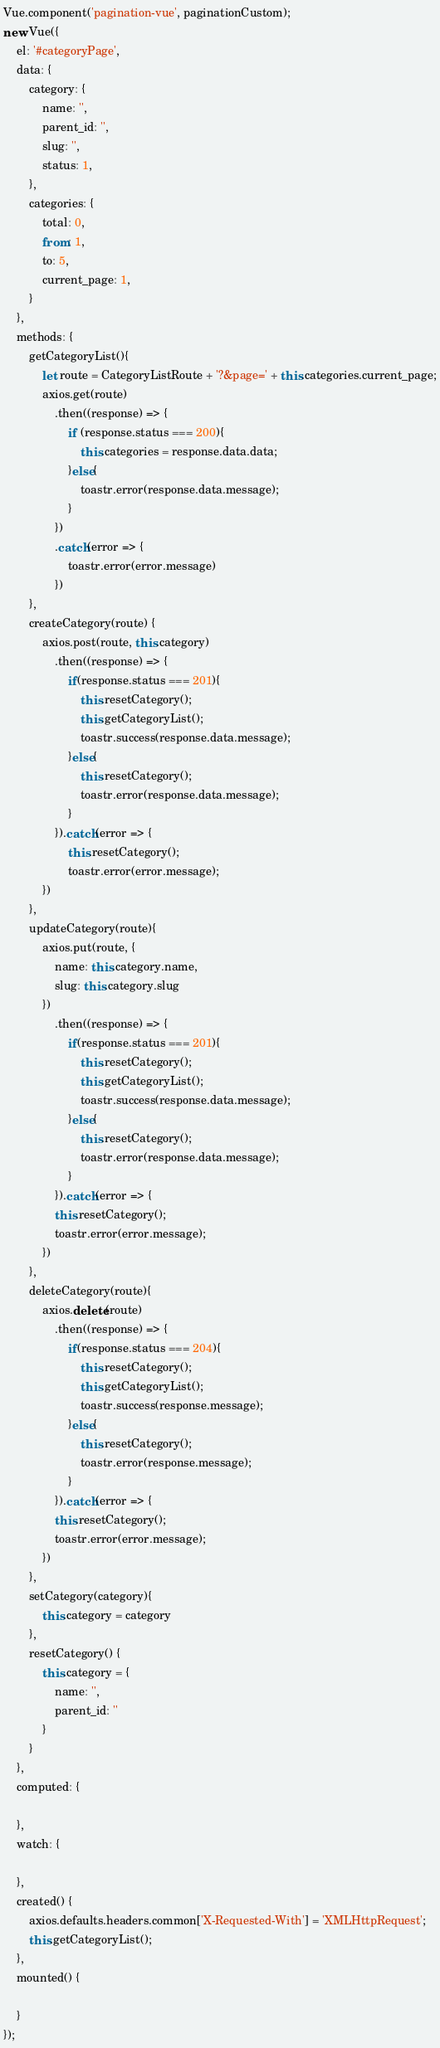Convert code to text. <code><loc_0><loc_0><loc_500><loc_500><_JavaScript_>Vue.component('pagination-vue', paginationCustom);
new Vue({
    el: '#categoryPage',
    data: {
        category: {
            name: '',
            parent_id: '',
            slug: '',
            status: 1,
        },
        categories: {
            total: 0,
            from: 1,
            to: 5,
            current_page: 1,
        }
    },
    methods: {
        getCategoryList(){
            let route = CategoryListRoute + '?&page=' + this.categories.current_page;
            axios.get(route)
                .then((response) => {
                    if (response.status === 200){
                        this.categories = response.data.data;
                    }else{
                        toastr.error(response.data.message);
                    }
                })
                .catch(error => {
                    toastr.error(error.message)
                })
        },
        createCategory(route) {
            axios.post(route, this.category)
                .then((response) => {
                    if(response.status === 201){
                        this.resetCategory();
                        this.getCategoryList();
                        toastr.success(response.data.message);
                    }else{
                        this.resetCategory();
                        toastr.error(response.data.message);
                    }
                }).catch(error => {
                    this.resetCategory();
                    toastr.error(error.message);
            })
        },
        updateCategory(route){
            axios.put(route, {
                name: this.category.name,
                slug: this.category.slug
            })
                .then((response) => {
                    if(response.status === 201){
                        this.resetCategory();
                        this.getCategoryList();
                        toastr.success(response.data.message);
                    }else{
                        this.resetCategory();
                        toastr.error(response.data.message);
                    }
                }).catch(error => {
                this.resetCategory();
                toastr.error(error.message);
            })
        },
        deleteCategory(route){
            axios.delete(route)
                .then((response) => {
                    if(response.status === 204){
                        this.resetCategory();
                        this.getCategoryList();
                        toastr.success(response.message);
                    }else{
                        this.resetCategory();
                        toastr.error(response.message);
                    }
                }).catch(error => {
                this.resetCategory();
                toastr.error(error.message);
            })
        },
        setCategory(category){
            this.category = category
        },
        resetCategory() {
            this.category = {
                name: '',
                parent_id: ''
            }
        }
    },
    computed: {

    },
    watch: {

    },
    created() {
        axios.defaults.headers.common['X-Requested-With'] = 'XMLHttpRequest';
        this.getCategoryList();
    },
    mounted() {

    }
});</code> 